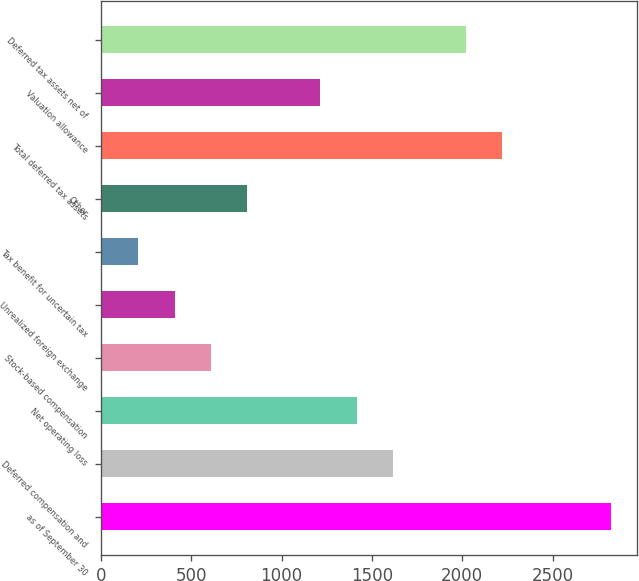Convert chart. <chart><loc_0><loc_0><loc_500><loc_500><bar_chart><fcel>as of September 30<fcel>Deferred compensation and<fcel>Net operating loss<fcel>Stock-based compensation<fcel>Unrealized foreign exchange<fcel>Tax benefit for uncertain tax<fcel>Other<fcel>Total deferred tax assets<fcel>Valuation allowance<fcel>Deferred tax assets net of<nl><fcel>2823.96<fcel>1616.52<fcel>1415.28<fcel>610.32<fcel>409.08<fcel>207.84<fcel>811.56<fcel>2220.24<fcel>1214.04<fcel>2019<nl></chart> 